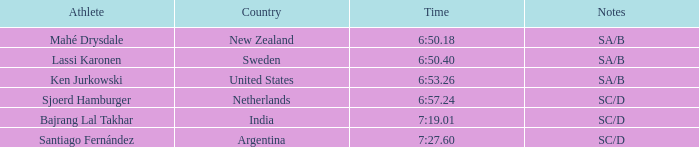What is the combined score of the ranks for india? 5.0. 